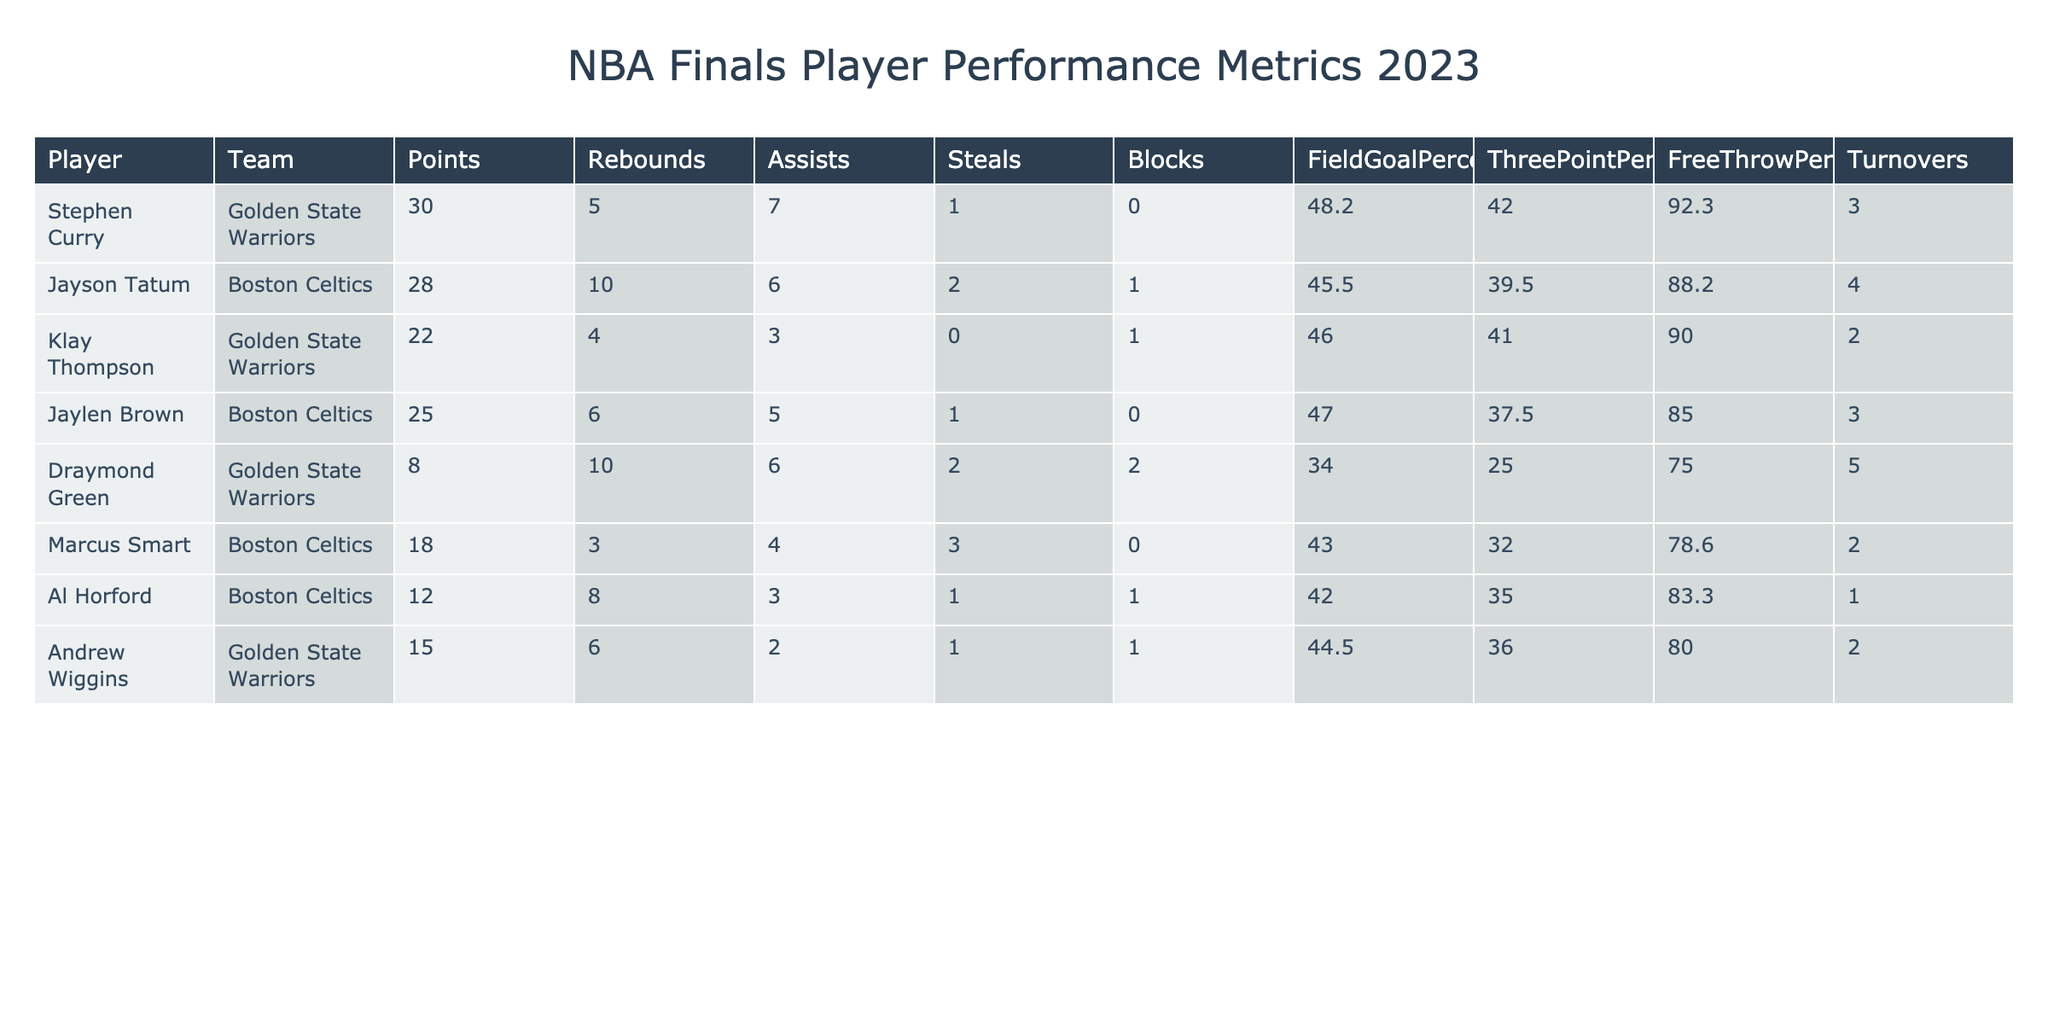What is the highest points scored by a player in the 2023 NBA Finals? The table shows that Stephen Curry scored 30 points, which is the highest among all players listed.
Answer: 30 Which player had the most rebounds in the game? Jayson Tatum had the most rebounds with a total of 10, as shown in the "Rebounds" column.
Answer: 10 What is the average free throw percentage for the players listed in the table? To find the average free throw percentage, add up the percentages: 92.3 + 88.2 + 90.0 + 85.0 + 75.0 + 78.6 + 83.3 + 80.0 = 792.4. Then divide by the number of players (8), which results in 792.4 / 8 = 99.05.
Answer: 99.05 Did any player score more than 25 points and have at least 5 rebounds? Both Jayson Tatum (28 points, 10 rebounds) and Jaylen Brown (25 points, 6 rebounds) meet this criterion. Thus, the answer is yes.
Answer: Yes Which player's assists contributed the most to their team’s overall gameplay? Stephen Curry assisted 7 times, which is the highest in the assists column compared to other players listed. This high assist number shows his playmaking contribution.
Answer: 7 What is the total number of turnovers by Golden State Warriors players in the finals? Golden State Warriors players are Stephen Curry (3), Klay Thompson (2), Draymond Green (5), and Andrew Wiggins (2). Adding these gives a total of 3 + 2 + 5 + 2 = 12 turnovers.
Answer: 12 Did Marcus Smart have a higher field goal percentage than Draymond Green? Yes, Marcus Smart's field goal percentage is 43.0, which is greater than Draymond Green’s field goal percentage of 34.0.
Answer: Yes Who had a better three-point shooting percentage, Klay Thompson or Jaylen Brown? Klay Thompson achieved a three-point shooting percentage of 41.0, while Jaylen Brown had 37.5. Since 41.0 is greater than 37.5, Klay Thompson had the better performance.
Answer: Klay Thompson 